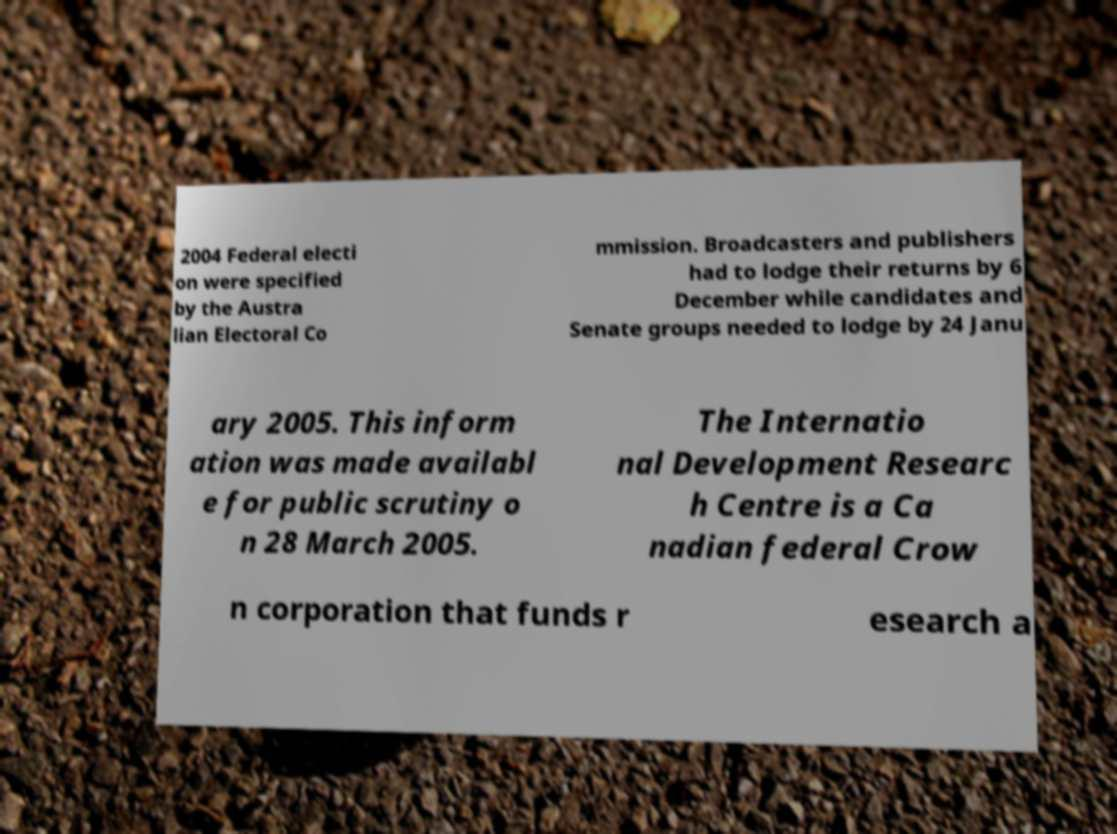Can you read and provide the text displayed in the image?This photo seems to have some interesting text. Can you extract and type it out for me? 2004 Federal electi on were specified by the Austra lian Electoral Co mmission. Broadcasters and publishers had to lodge their returns by 6 December while candidates and Senate groups needed to lodge by 24 Janu ary 2005. This inform ation was made availabl e for public scrutiny o n 28 March 2005. The Internatio nal Development Researc h Centre is a Ca nadian federal Crow n corporation that funds r esearch a 